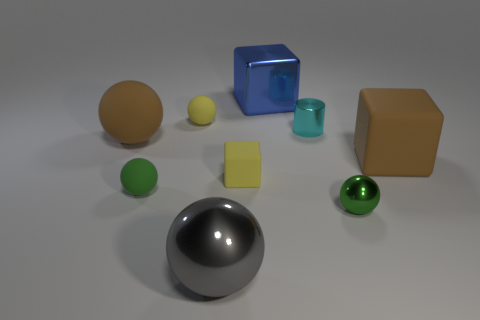Add 1 green rubber balls. How many objects exist? 10 Subtract all large blocks. How many blocks are left? 1 Subtract 3 blocks. How many blocks are left? 0 Subtract all green balls. How many balls are left? 3 Subtract all balls. How many objects are left? 4 Subtract all blue spheres. Subtract all blue cubes. How many spheres are left? 5 Subtract all blue balls. How many yellow cubes are left? 1 Subtract all rubber objects. Subtract all big blocks. How many objects are left? 2 Add 1 big gray things. How many big gray things are left? 2 Add 4 small rubber spheres. How many small rubber spheres exist? 6 